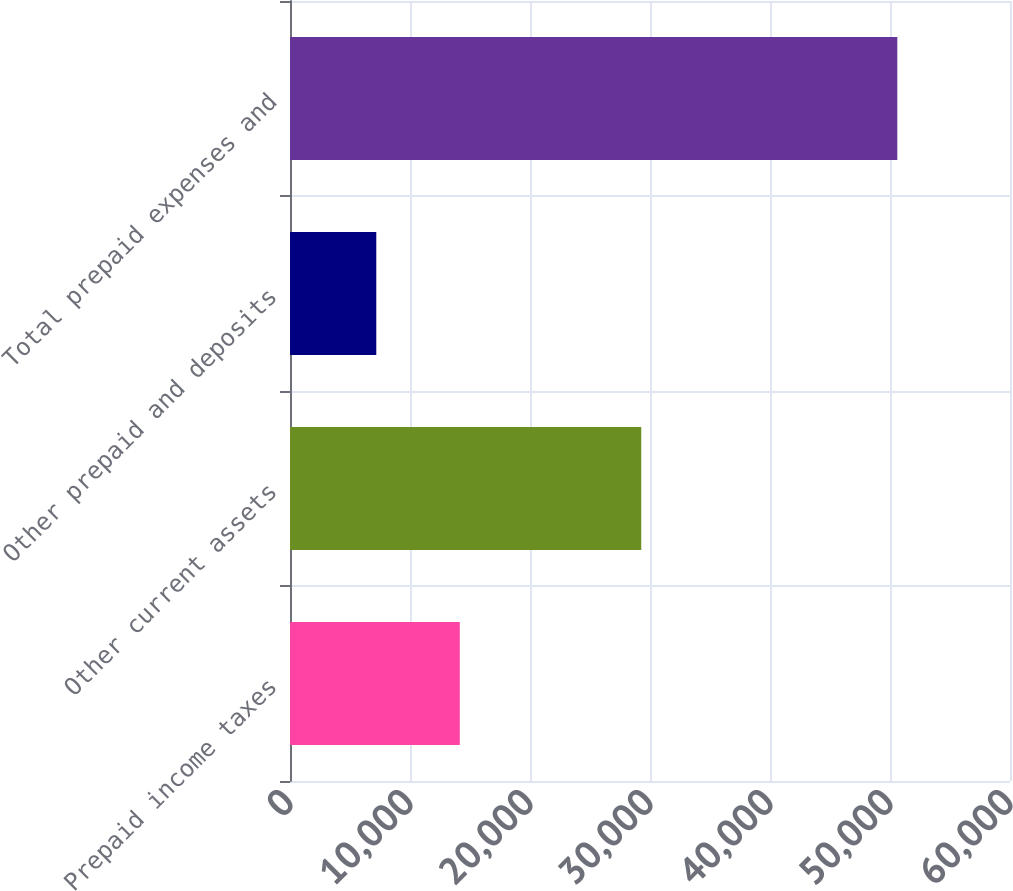<chart> <loc_0><loc_0><loc_500><loc_500><bar_chart><fcel>Prepaid income taxes<fcel>Other current assets<fcel>Other prepaid and deposits<fcel>Total prepaid expenses and<nl><fcel>14150<fcel>29270<fcel>7190<fcel>50610<nl></chart> 